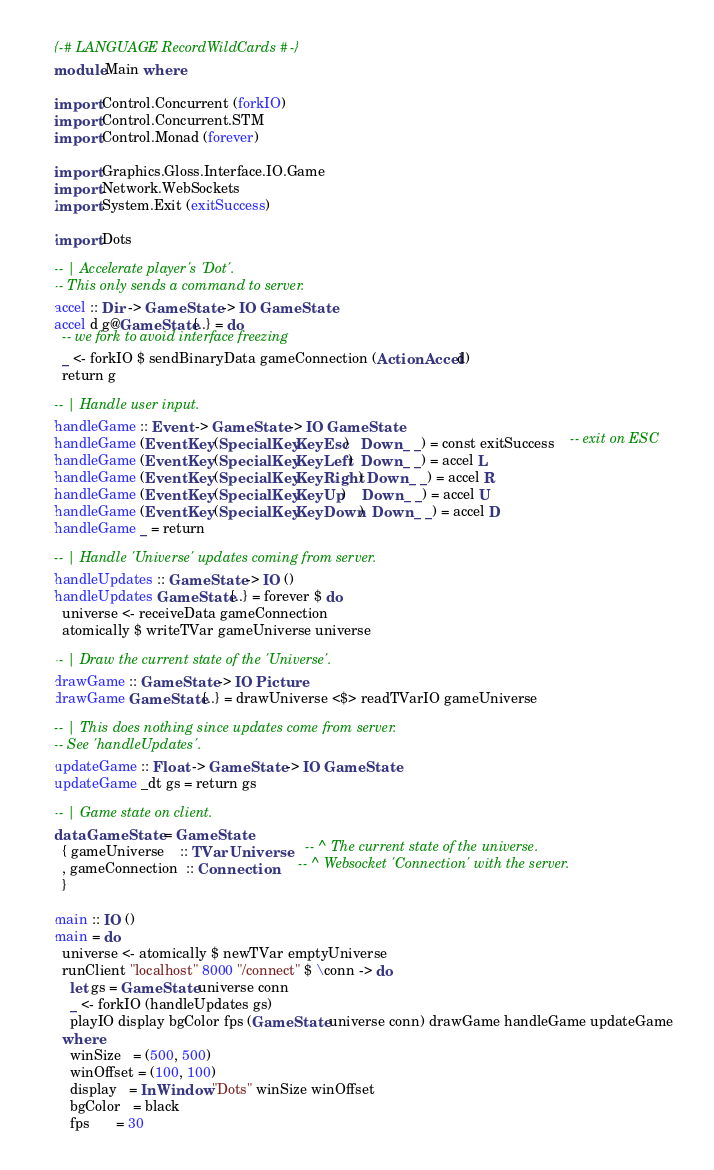Convert code to text. <code><loc_0><loc_0><loc_500><loc_500><_Haskell_>{-# LANGUAGE RecordWildCards #-}
module Main where

import Control.Concurrent (forkIO)
import Control.Concurrent.STM
import Control.Monad (forever)

import Graphics.Gloss.Interface.IO.Game
import Network.WebSockets
import System.Exit (exitSuccess)

import Dots

-- | Accelerate player's 'Dot'.
-- This only sends a command to server.
accel :: Dir -> GameState -> IO GameState
accel d g@GameState{..} = do
  -- we fork to avoid interface freezing
  _ <- forkIO $ sendBinaryData gameConnection (ActionAccel d)
  return g

-- | Handle user input.
handleGame :: Event -> GameState -> IO GameState
handleGame (EventKey (SpecialKey KeyEsc)   Down _ _) = const exitSuccess    -- exit on ESC
handleGame (EventKey (SpecialKey KeyLeft)  Down _ _) = accel L
handleGame (EventKey (SpecialKey KeyRight) Down _ _) = accel R
handleGame (EventKey (SpecialKey KeyUp)    Down _ _) = accel U
handleGame (EventKey (SpecialKey KeyDown)  Down _ _) = accel D
handleGame _ = return

-- | Handle 'Universe' updates coming from server.
handleUpdates :: GameState -> IO ()
handleUpdates GameState{..} = forever $ do
  universe <- receiveData gameConnection
  atomically $ writeTVar gameUniverse universe

-- | Draw the current state of the 'Universe'.
drawGame :: GameState -> IO Picture
drawGame GameState{..} = drawUniverse <$> readTVarIO gameUniverse

-- | This does nothing since updates come from server.
-- See 'handleUpdates'.
updateGame :: Float -> GameState -> IO GameState
updateGame _dt gs = return gs

-- | Game state on client.
data GameState = GameState
  { gameUniverse    :: TVar Universe    -- ^ The current state of the universe.
  , gameConnection  :: Connection       -- ^ Websocket 'Connection' with the server.
  }

main :: IO ()
main = do
  universe <- atomically $ newTVar emptyUniverse
  runClient "localhost" 8000 "/connect" $ \conn -> do
    let gs = GameState universe conn
    _ <- forkIO (handleUpdates gs)
    playIO display bgColor fps (GameState universe conn) drawGame handleGame updateGame
  where
    winSize   = (500, 500)
    winOffset = (100, 100)
    display   = InWindow "Dots" winSize winOffset
    bgColor   = black
    fps       = 30
</code> 